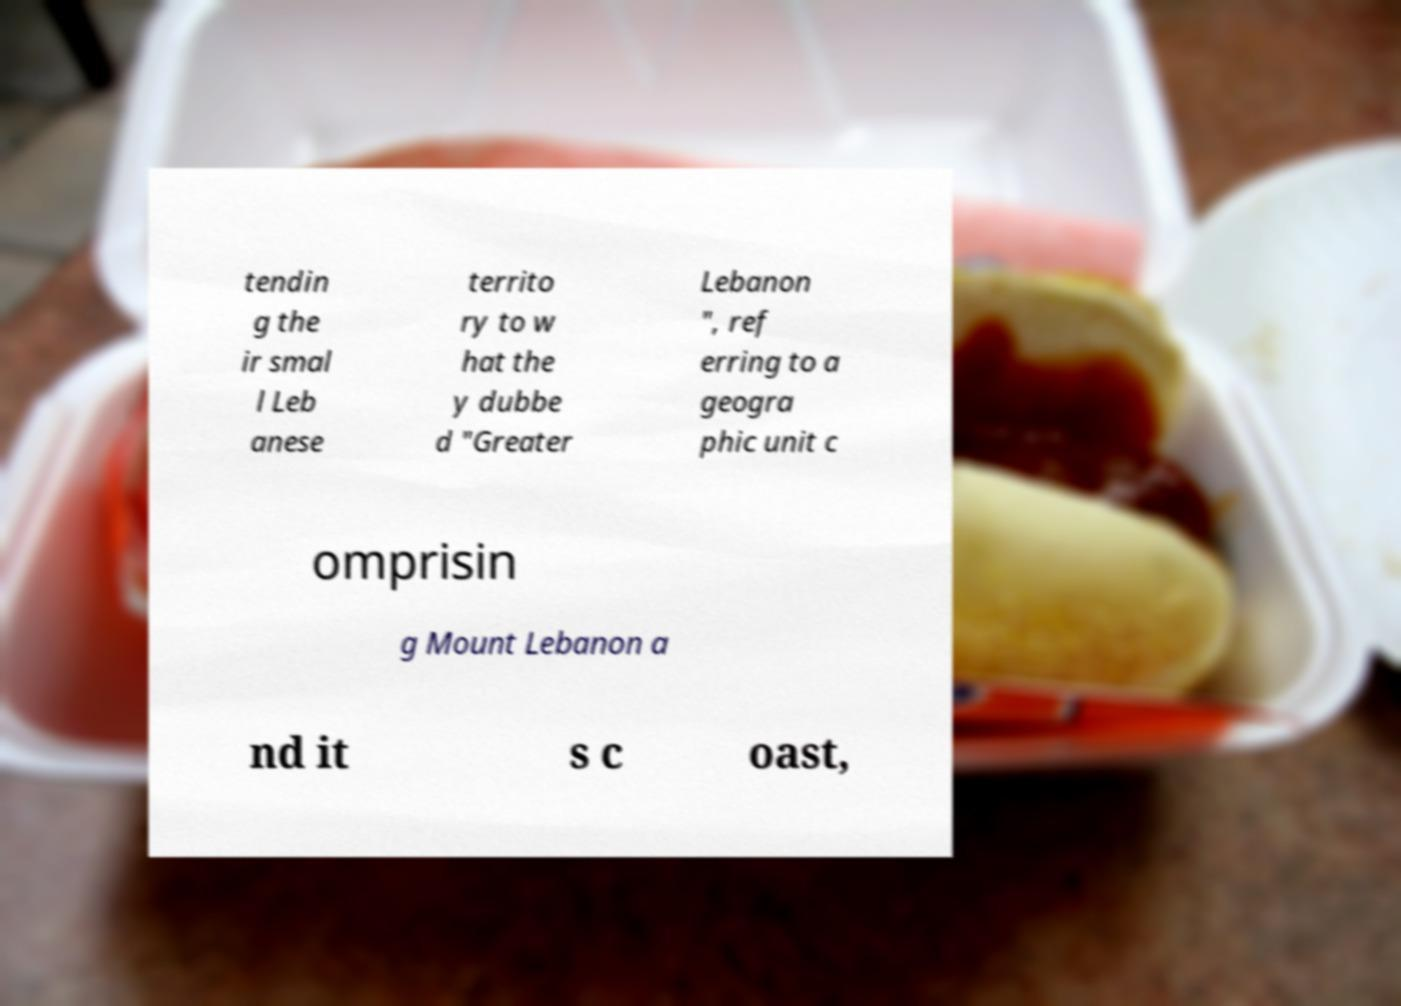Could you assist in decoding the text presented in this image and type it out clearly? tendin g the ir smal l Leb anese territo ry to w hat the y dubbe d "Greater Lebanon ", ref erring to a geogra phic unit c omprisin g Mount Lebanon a nd it s c oast, 